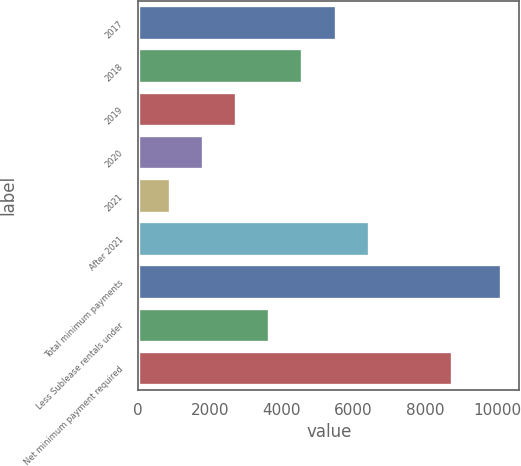<chart> <loc_0><loc_0><loc_500><loc_500><bar_chart><fcel>2017<fcel>2018<fcel>2019<fcel>2020<fcel>2021<fcel>After 2021<fcel>Total minimum payments<fcel>Less Sublease rentals under<fcel>Net minimum payment required<nl><fcel>5500<fcel>4577<fcel>2731<fcel>1808<fcel>885<fcel>6423<fcel>10115<fcel>3654<fcel>8736<nl></chart> 